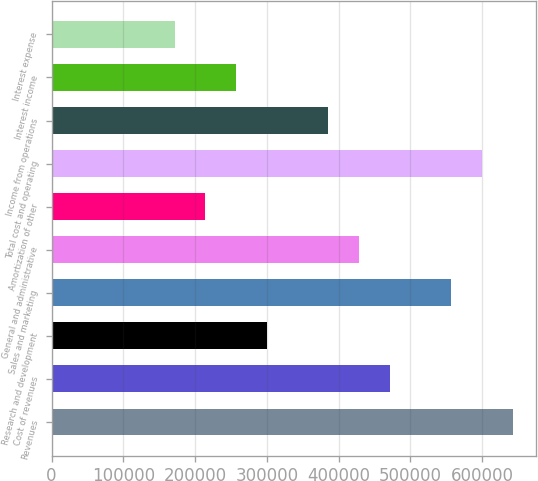Convert chart. <chart><loc_0><loc_0><loc_500><loc_500><bar_chart><fcel>Revenues<fcel>Cost of revenues<fcel>Research and development<fcel>Sales and marketing<fcel>General and administrative<fcel>Amortization of other<fcel>Total cost and operating<fcel>Income from operations<fcel>Interest income<fcel>Interest expense<nl><fcel>643008<fcel>471539<fcel>300071<fcel>557274<fcel>428672<fcel>214336<fcel>600141<fcel>385805<fcel>257203<fcel>171469<nl></chart> 